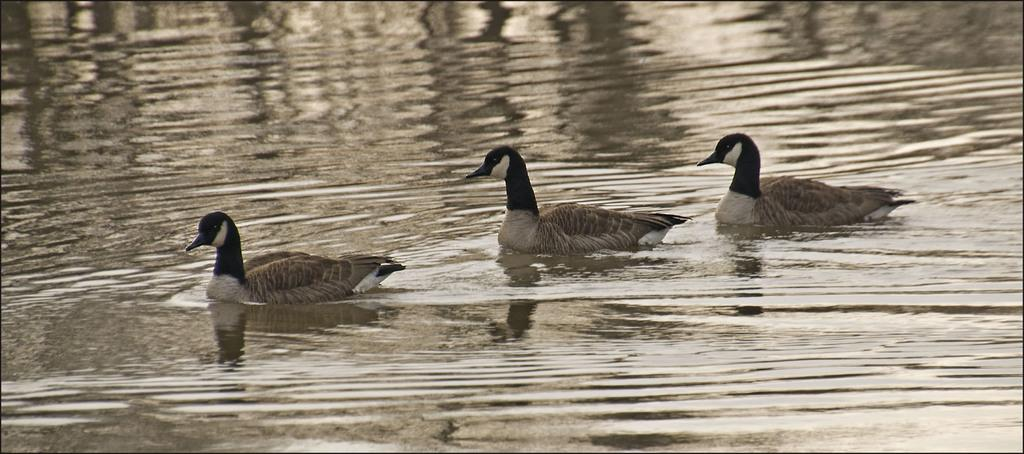How many ducks are present in the image? There are 3 ducks in the picture. Where are the ducks located in the image? The ducks are on the water. What type of cactus can be seen in the background of the image? There is no cactus present in the image; it features 3 ducks on the water. How many pigs are swimming with the ducks in the image? There are no pigs present in the image; it features 3 ducks on the water. 